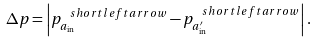<formula> <loc_0><loc_0><loc_500><loc_500>\Delta p = \left | p ^ { \ s h o r t l e f t a r r o w } _ { a _ { \text {in} } } - p ^ { \ s h o r t l e f t a r r o w } _ { a _ { \text {in} } ^ { \prime } } \right | .</formula> 